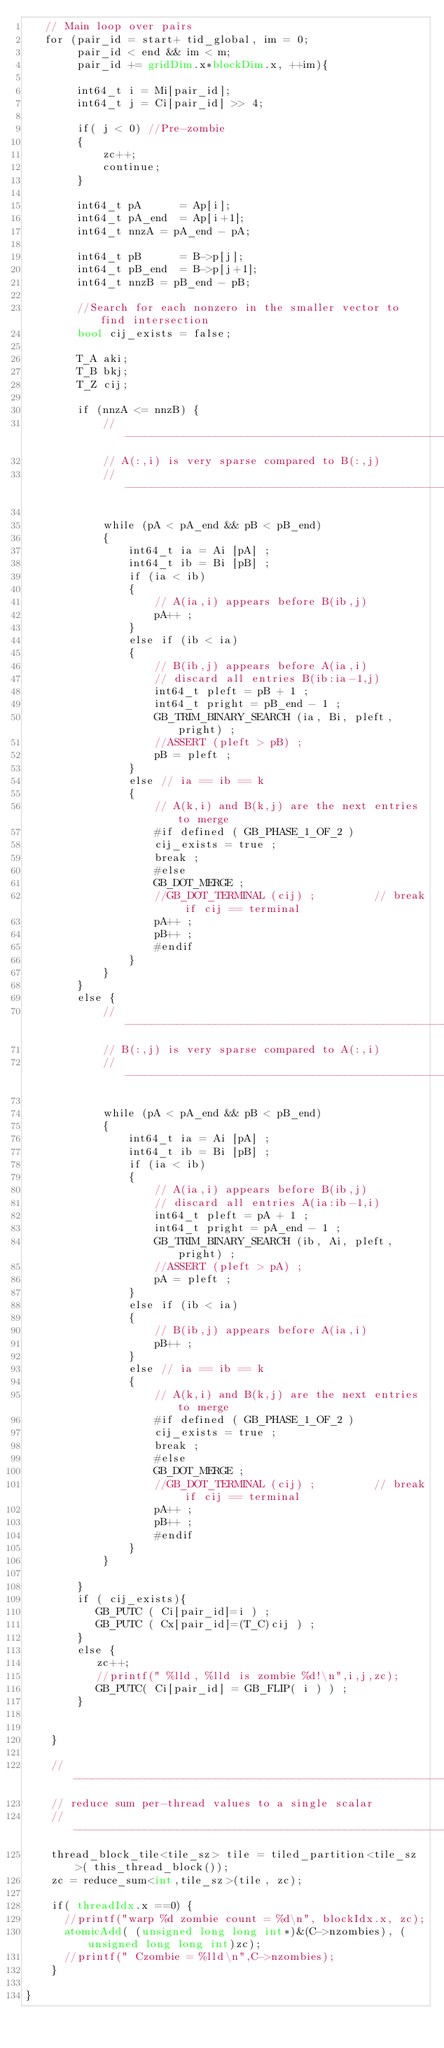Convert code to text. <code><loc_0><loc_0><loc_500><loc_500><_Cuda_>   // Main loop over pairs 
   for (pair_id = start+ tid_global, im = 0; 
        pair_id < end && im < m;  
        pair_id += gridDim.x*blockDim.x, ++im){

        int64_t i = Mi[pair_id];
        int64_t j = Ci[pair_id] >> 4;

        if( j < 0) //Pre-zombie
        {
            zc++;
            continue;
        }

        int64_t pA      = Ap[i];
        int64_t pA_end  = Ap[i+1];
        int64_t nnzA = pA_end - pA;

        int64_t pB      = B->p[j]; 
        int64_t pB_end  = B->p[j+1]; 
        int64_t nnzB = pB_end - pB;

        //Search for each nonzero in the smaller vector to find intersection 
        bool cij_exists = false;

        T_A aki;
        T_B bkj;
        T_Z cij;

        if (nnzA <= nnzB) {
            //----------------------------------------------------------------------
            // A(:,i) is very sparse compared to B(:,j)
            //----------------------------------------------------------------------

            while (pA < pA_end && pB < pB_end)
            {
                int64_t ia = Ai [pA] ;
                int64_t ib = Bi [pB] ;
                if (ia < ib)
                { 
                    // A(ia,i) appears before B(ib,j)
                    pA++ ;
                }
                else if (ib < ia)
                { 
                    // B(ib,j) appears before A(ia,i)
                    // discard all entries B(ib:ia-1,j)
                    int64_t pleft = pB + 1 ;
                    int64_t pright = pB_end - 1 ;
                    GB_TRIM_BINARY_SEARCH (ia, Bi, pleft, pright) ;
                    //ASSERT (pleft > pB) ;
                    pB = pleft ;
                }
                else // ia == ib == k
                { 
                    // A(k,i) and B(k,j) are the next entries to merge
                    #if defined ( GB_PHASE_1_OF_2 )
                    cij_exists = true ;
                    break ;
                    #else
                    GB_DOT_MERGE ;
                    //GB_DOT_TERMINAL (cij) ;         // break if cij == terminal
                    pA++ ;
                    pB++ ;
                    #endif
                }
            }
        }
        else {
            //----------------------------------------------------------------------
            // B(:,j) is very sparse compared to A(:,i)
            //----------------------------------------------------------------------

            while (pA < pA_end && pB < pB_end)
            {
                int64_t ia = Ai [pA] ;
                int64_t ib = Bi [pB] ;
                if (ia < ib)
                { 
                    // A(ia,i) appears before B(ib,j)
                    // discard all entries A(ia:ib-1,i)
                    int64_t pleft = pA + 1 ;
                    int64_t pright = pA_end - 1 ;
                    GB_TRIM_BINARY_SEARCH (ib, Ai, pleft, pright) ;
                    //ASSERT (pleft > pA) ;
                    pA = pleft ;
                }
                else if (ib < ia)
                { 
                    // B(ib,j) appears before A(ia,i)
                    pB++ ;
                }
                else // ia == ib == k
                { 
                    // A(k,i) and B(k,j) are the next entries to merge
                    #if defined ( GB_PHASE_1_OF_2 )
                    cij_exists = true ;
                    break ;
                    #else
                    GB_DOT_MERGE ;
                    //GB_DOT_TERMINAL (cij) ;         // break if cij == terminal
                    pA++ ;
                    pB++ ;
                    #endif
                }
            }

        }
        if ( cij_exists){
           GB_PUTC ( Ci[pair_id]=i ) ;
           GB_PUTC ( Cx[pair_id]=(T_C)cij ) ;
        }
        else {
           zc++; 
           //printf(" %lld, %lld is zombie %d!\n",i,j,zc);
           GB_PUTC( Ci[pair_id] = GB_FLIP( i ) ) ;
        }


    }

    //--------------------------------------------------------------------------
    // reduce sum per-thread values to a single scalar
    //--------------------------------------------------------------------------
    thread_block_tile<tile_sz> tile = tiled_partition<tile_sz>( this_thread_block());
    zc = reduce_sum<int,tile_sz>(tile, zc);

    if( threadIdx.x ==0) {
      //printf("warp %d zombie count = %d\n", blockIdx.x, zc);
      atomicAdd( (unsigned long long int*)&(C->nzombies), (unsigned long long int)zc);
      //printf(" Czombie = %lld\n",C->nzombies);
    }

}

</code> 